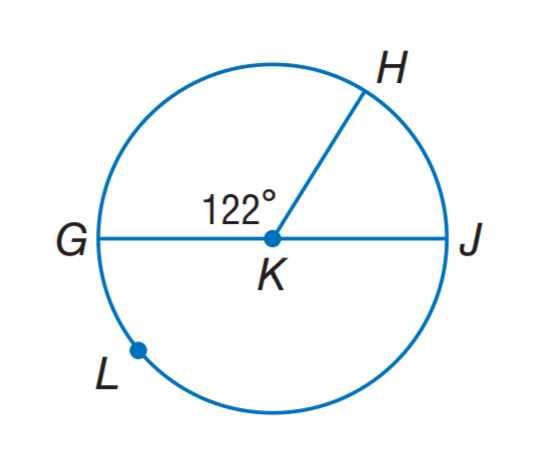Answer the mathemtical geometry problem and directly provide the correct option letter.
Question: G J is a diameter of \odot K. Find m \widehat G H.
Choices: A: 58 B: 61 C: 116 D: 122 D 